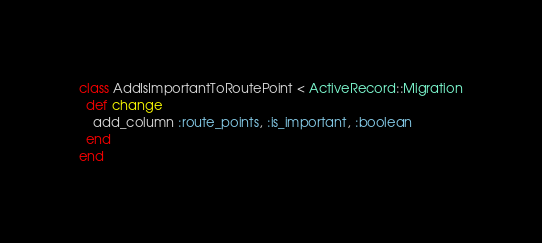<code> <loc_0><loc_0><loc_500><loc_500><_Ruby_>class AddIsImportantToRoutePoint < ActiveRecord::Migration
  def change
    add_column :route_points, :is_important, :boolean
  end
end
</code> 